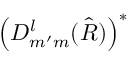<formula> <loc_0><loc_0><loc_500><loc_500>\left ( D _ { m ^ { \prime } m } ^ { l } ( \hat { R } ) \right ) ^ { \ast }</formula> 